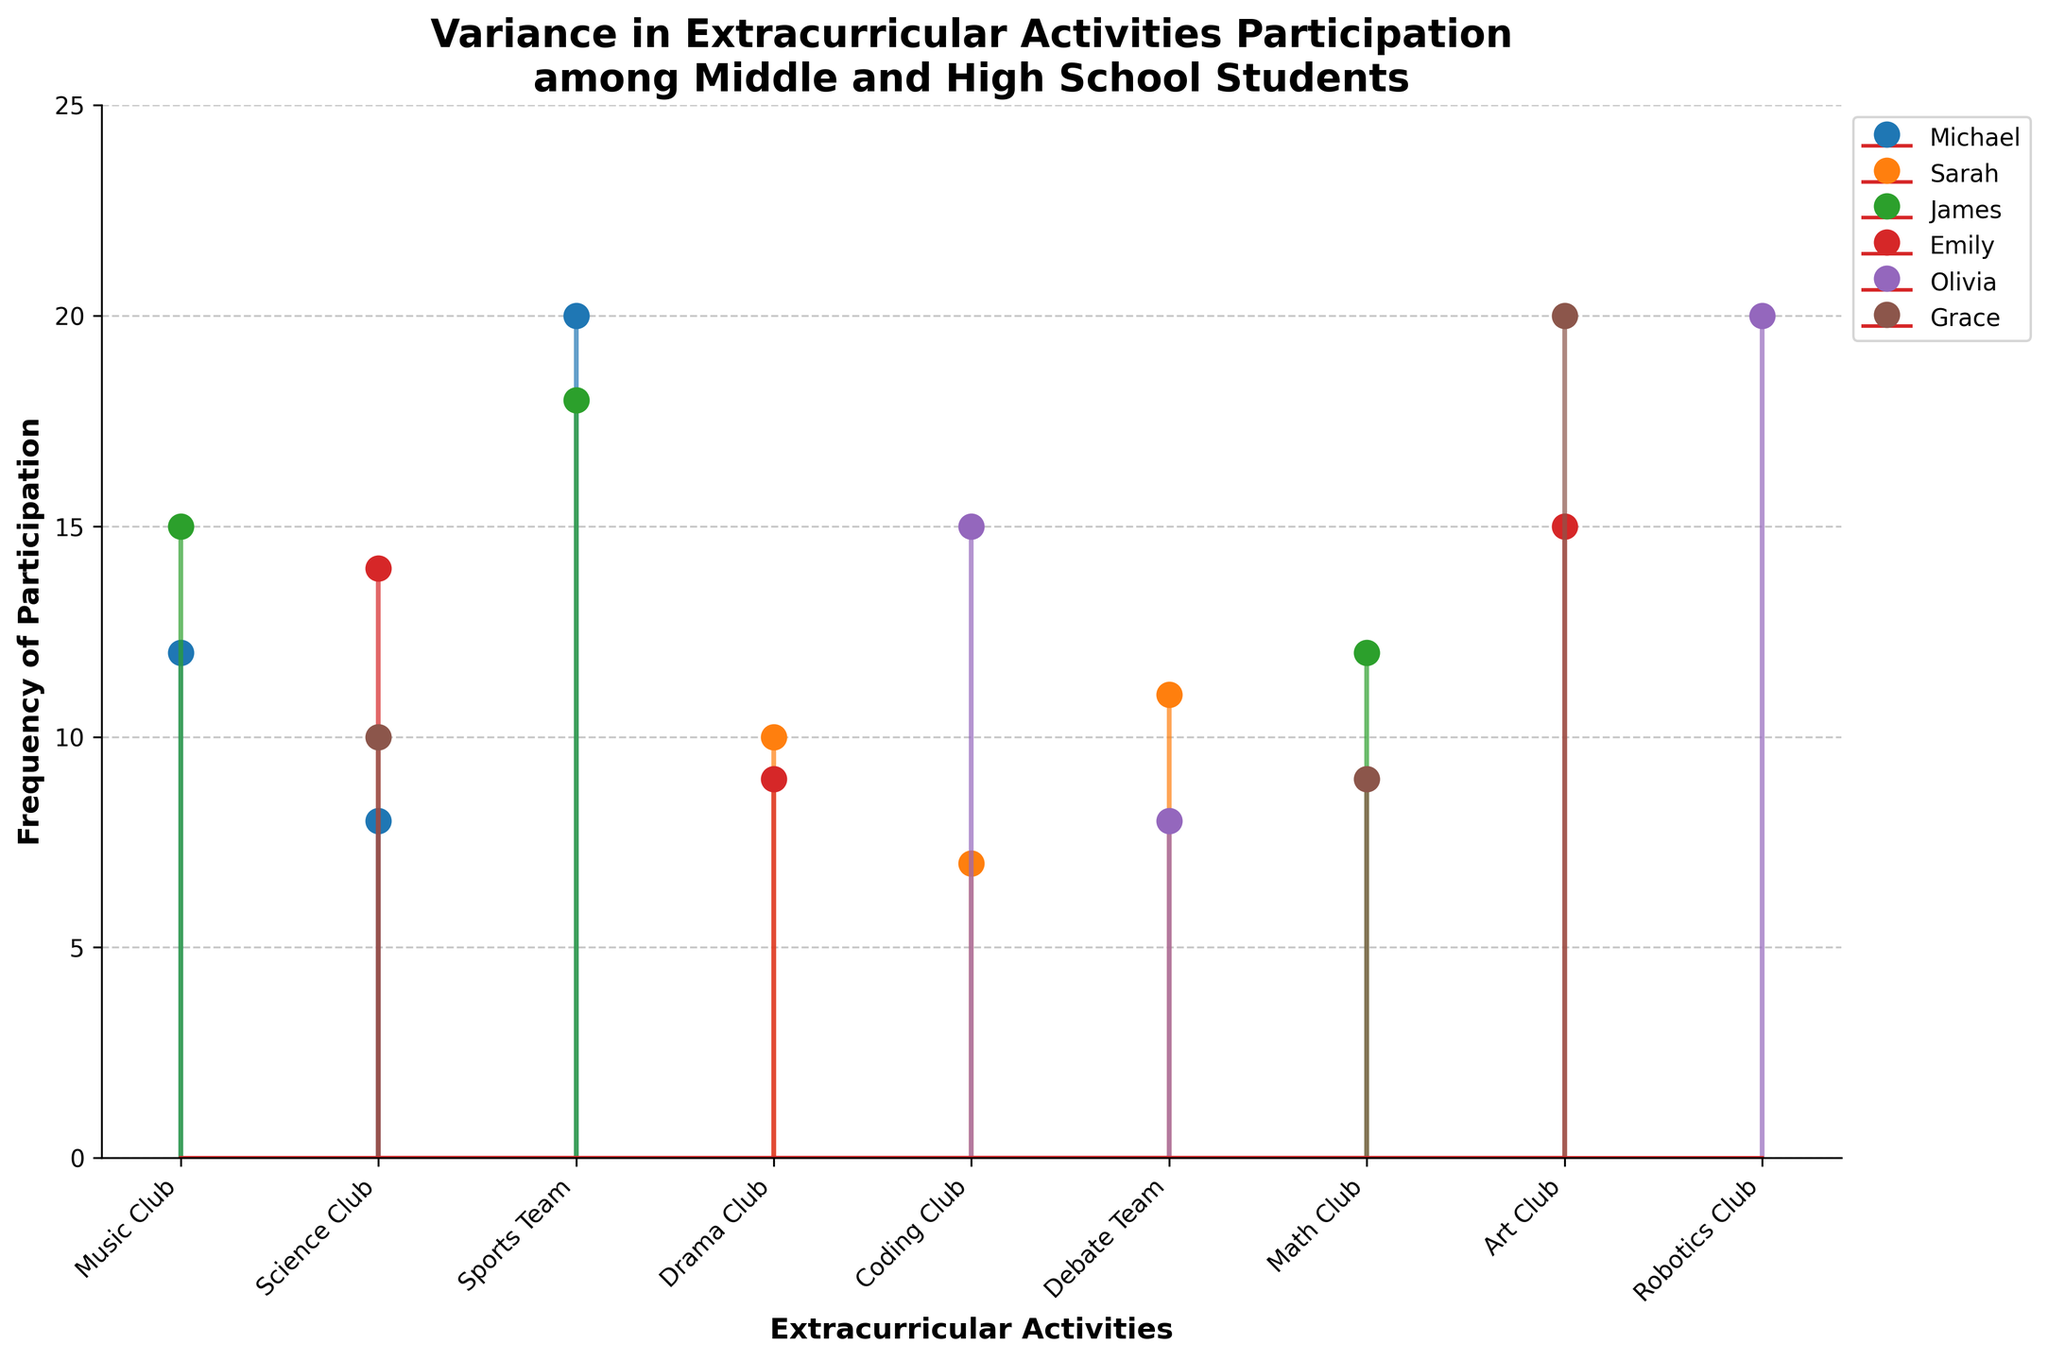What is the title of the figure? The title is displayed at the top of the figure and specifies the subject of the plot.
Answer: "Variance in Extracurricular Activities Participation among Middle and High School Students" Which activity has the highest participation from any student? To find this, look for the highest point on the y-axis and see which activity it corresponds to on the x-axis.
Answer: "Sports Team" by Michael with a frequency of 20 How many unique extracurricular activities are shown in the figure? Count the number of distinct labels on the x-axis, which represent the activities.
Answer: 9 Which student has the most diverse participation in extracurricular activities? Identify the student with the most number of distinct activities listed.
Answer: Michael and Sarah each have 3 different activities What is the average frequency of participation for Sarah? Sum the frequencies for Sarah and divide by the number of activities she participates in: (10 + 7 + 11)/3 = 28/3 ≈ 9.33
Answer: 9.33 Who participates in the Coding Club the most? Identify which student has the highest value in the "Coding Club" category.
Answer: Olivia Compare the participation frequency in Music Club between Michael and James. Who participates more? Look at the "Music Club" data points for both students and compare their y-axis values.
Answer: James (15 vs. 12) What is the total participation for all activities by Emily? Sum the frequencies of all activities Emily participates in: 15 (Art Club) + 14 (Science Club) + 9 (Drama Club) = 38.
Answer: 38 Which student participates in the Math Club, and what are their respective frequencies? Identify the students who have data points for the "Math Club" label and list their corresponding y-axis values.
Answer: James (12) and Grace (9) Which activity has the lowest participation frequency, and who is the student? Look for the lowest data point on the y-axis and see which activity and student it corresponds to.
Answer: Coding Club by Sarah (7) 